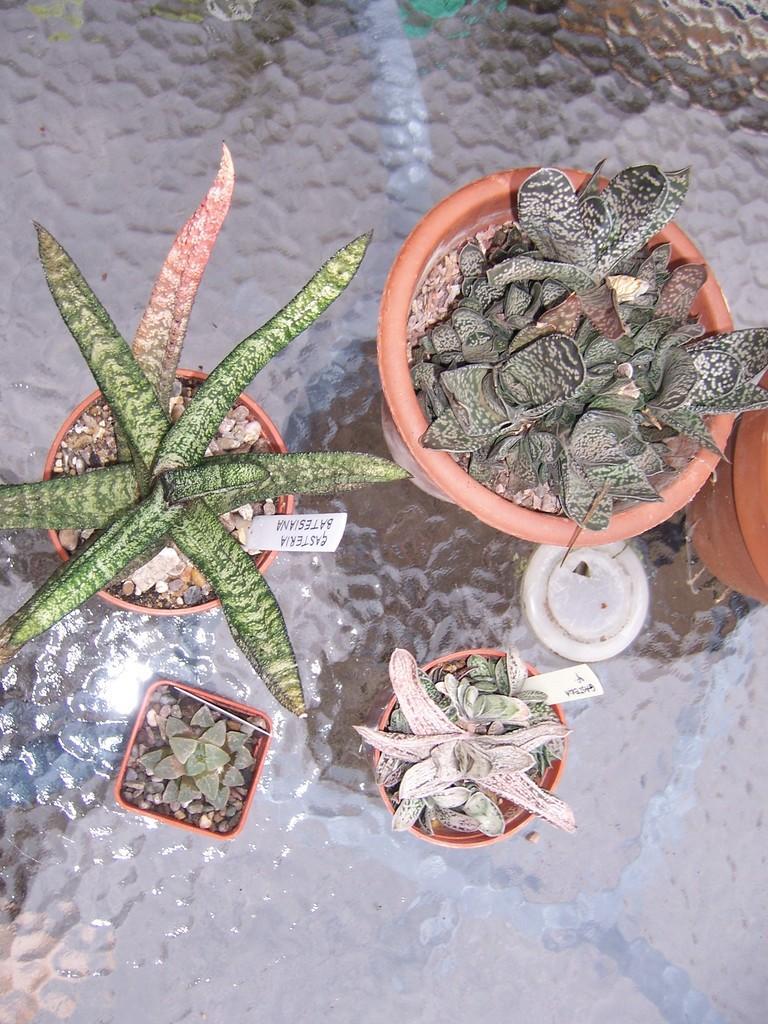Please provide a concise description of this image. In this picture, we see flower pots are placed on the glass table. We see the name tags are placed in each flower pot. 